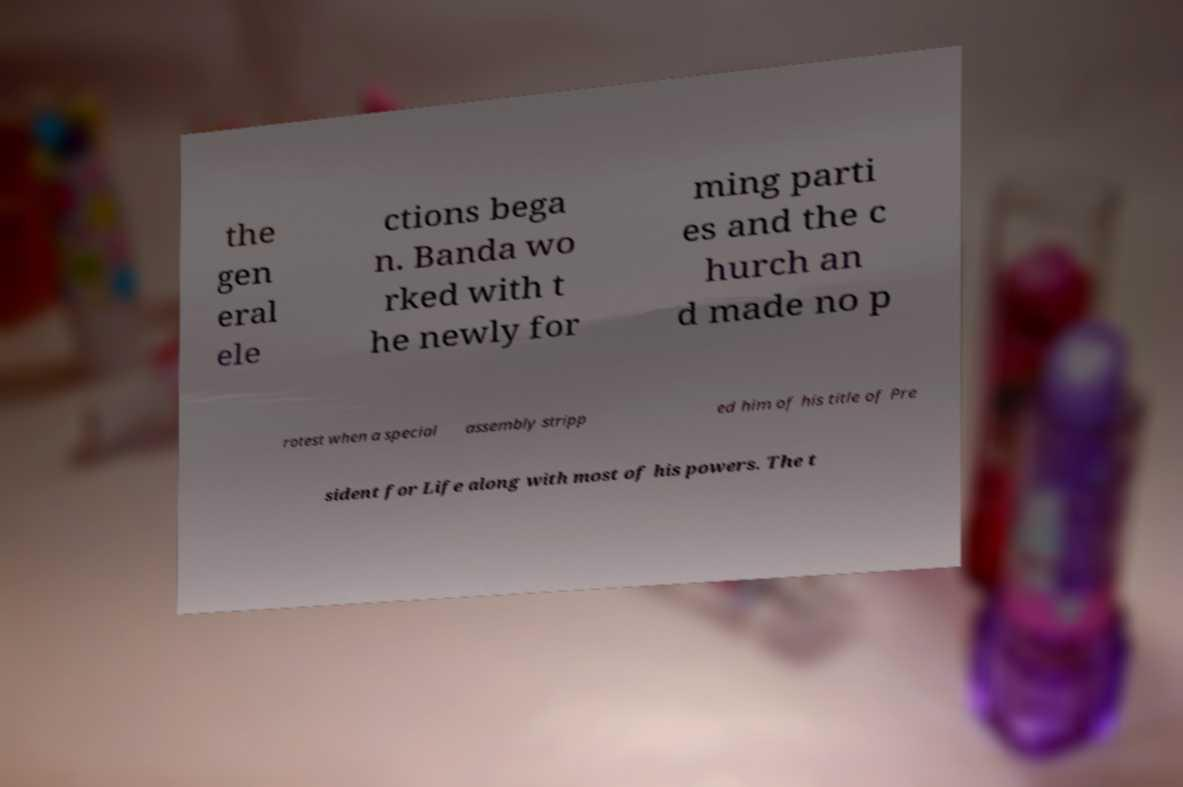Can you accurately transcribe the text from the provided image for me? the gen eral ele ctions bega n. Banda wo rked with t he newly for ming parti es and the c hurch an d made no p rotest when a special assembly stripp ed him of his title of Pre sident for Life along with most of his powers. The t 